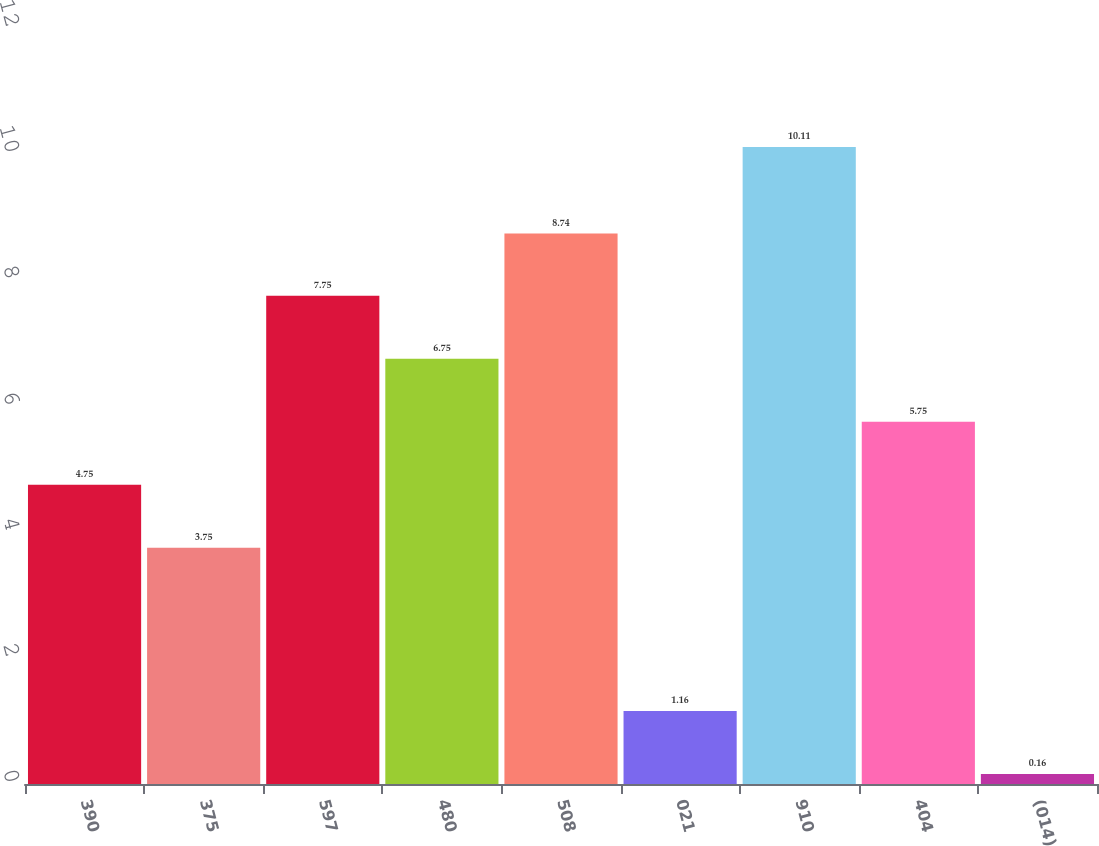<chart> <loc_0><loc_0><loc_500><loc_500><bar_chart><fcel>390<fcel>375<fcel>597<fcel>480<fcel>508<fcel>021<fcel>910<fcel>404<fcel>(014)<nl><fcel>4.75<fcel>3.75<fcel>7.75<fcel>6.75<fcel>8.74<fcel>1.16<fcel>10.11<fcel>5.75<fcel>0.16<nl></chart> 